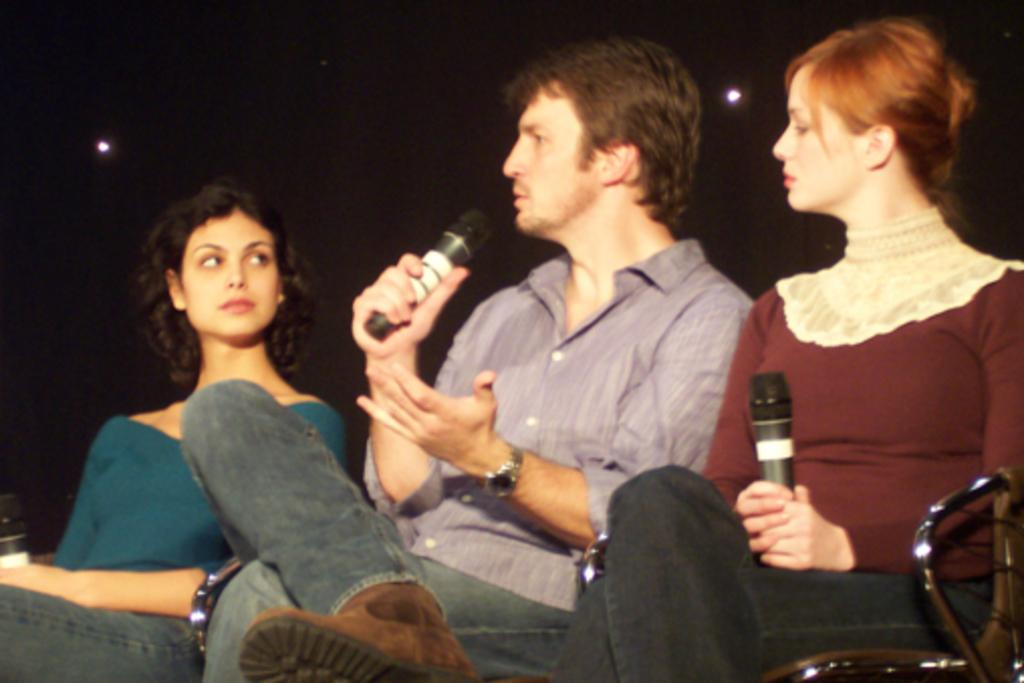How many people are in the image? There are three persons in the image. What are the persons doing in the image? The persons are sitting on chairs. Can you describe the woman in the image? The woman is in the image, and she is holding a mic. What type of reaction can be seen from the kitty in the image? There is no kitty present in the image, so no reaction can be observed. What is the tin used for in the image? There is no tin present in the image, so its purpose cannot be determined. 